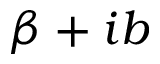<formula> <loc_0><loc_0><loc_500><loc_500>\beta + i b</formula> 